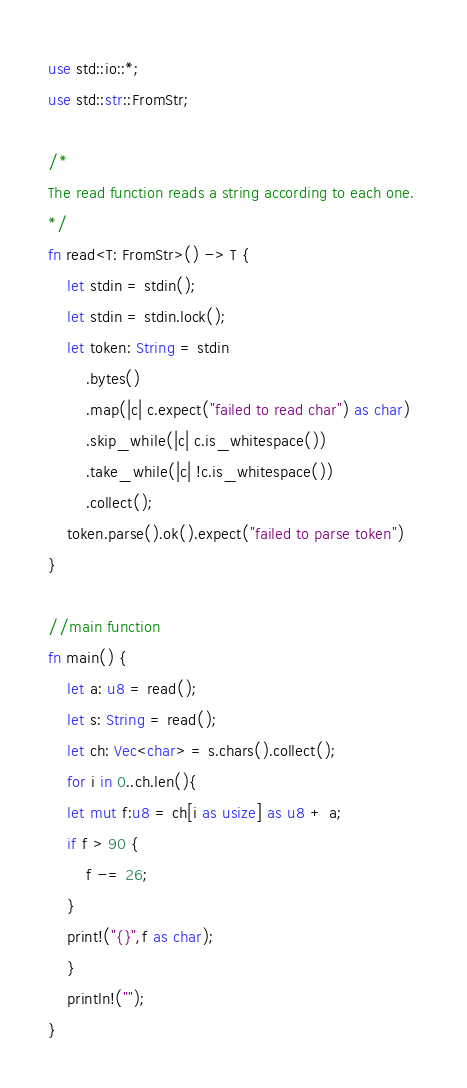<code> <loc_0><loc_0><loc_500><loc_500><_Rust_>use std::io::*;
use std::str::FromStr;
 
/* 
The read function reads a string according to each one. 
*/
fn read<T: FromStr>() -> T {
    let stdin = stdin();
    let stdin = stdin.lock();
    let token: String = stdin
        .bytes()
        .map(|c| c.expect("failed to read char") as char) 
        .skip_while(|c| c.is_whitespace())
        .take_while(|c| !c.is_whitespace())
        .collect();
    token.parse().ok().expect("failed to parse token")
}

//main function
fn main() {
    let a: u8 = read();
    let s: String = read();
    let ch: Vec<char> = s.chars().collect();
    for i in 0..ch.len(){
	let mut f:u8 = ch[i as usize] as u8 + a;
	if f > 90 {
	    f -= 26;
	}
	print!("{}",f as char);
    }
    println!("");
}
</code> 